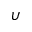<formula> <loc_0><loc_0><loc_500><loc_500>\upsilon</formula> 